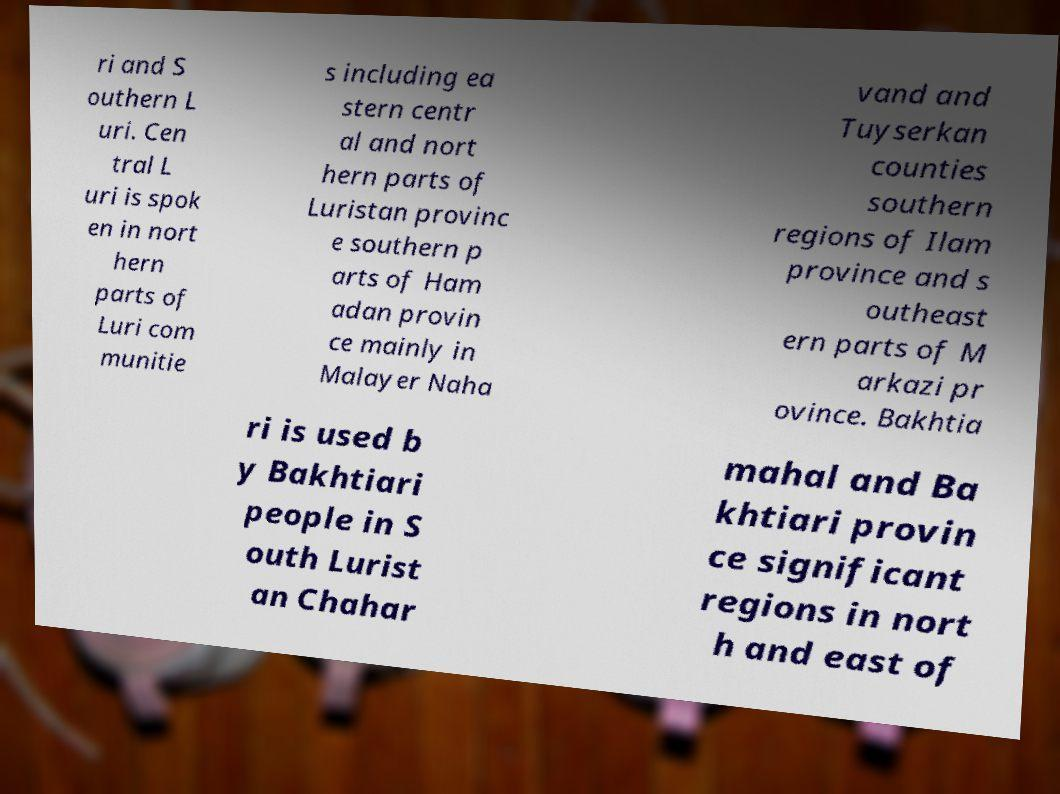There's text embedded in this image that I need extracted. Can you transcribe it verbatim? ri and S outhern L uri. Cen tral L uri is spok en in nort hern parts of Luri com munitie s including ea stern centr al and nort hern parts of Luristan provinc e southern p arts of Ham adan provin ce mainly in Malayer Naha vand and Tuyserkan counties southern regions of Ilam province and s outheast ern parts of M arkazi pr ovince. Bakhtia ri is used b y Bakhtiari people in S outh Lurist an Chahar mahal and Ba khtiari provin ce significant regions in nort h and east of 